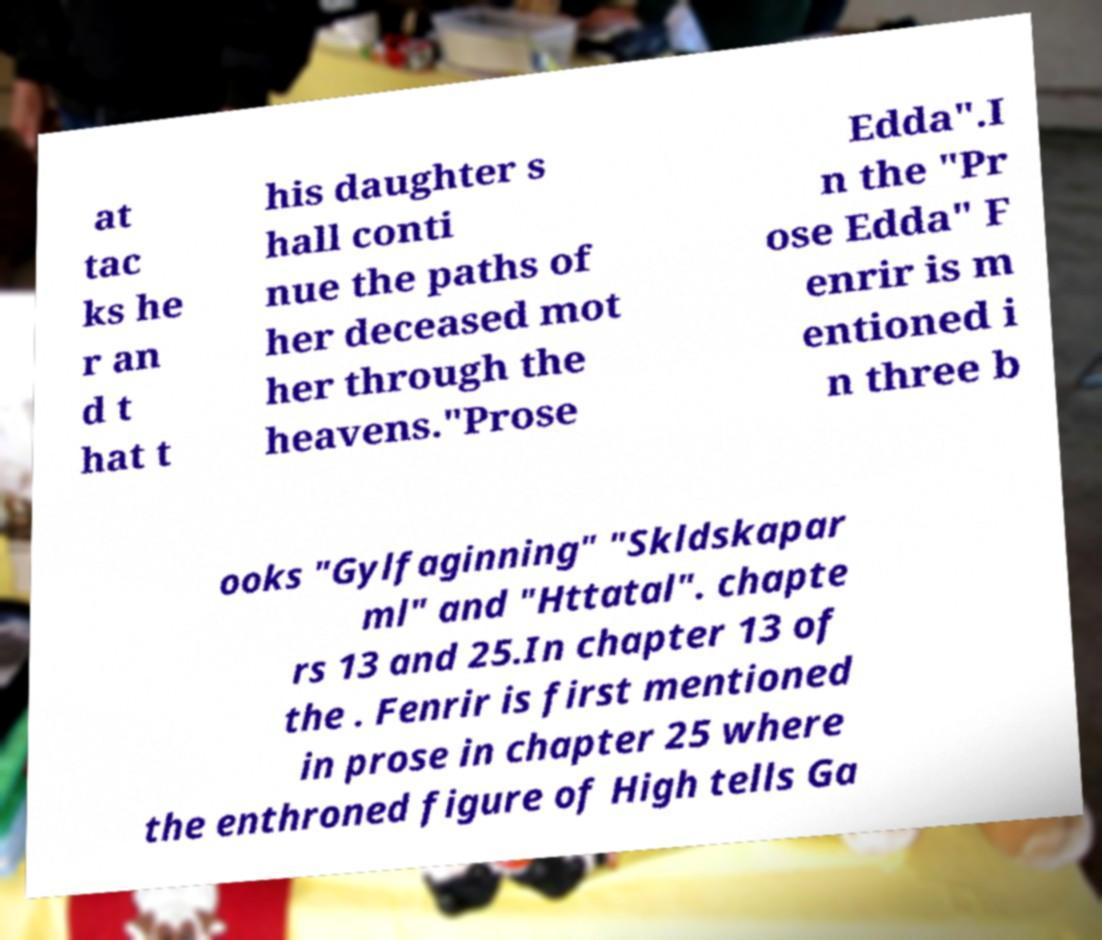There's text embedded in this image that I need extracted. Can you transcribe it verbatim? at tac ks he r an d t hat t his daughter s hall conti nue the paths of her deceased mot her through the heavens."Prose Edda".I n the "Pr ose Edda" F enrir is m entioned i n three b ooks "Gylfaginning" "Skldskapar ml" and "Httatal". chapte rs 13 and 25.In chapter 13 of the . Fenrir is first mentioned in prose in chapter 25 where the enthroned figure of High tells Ga 